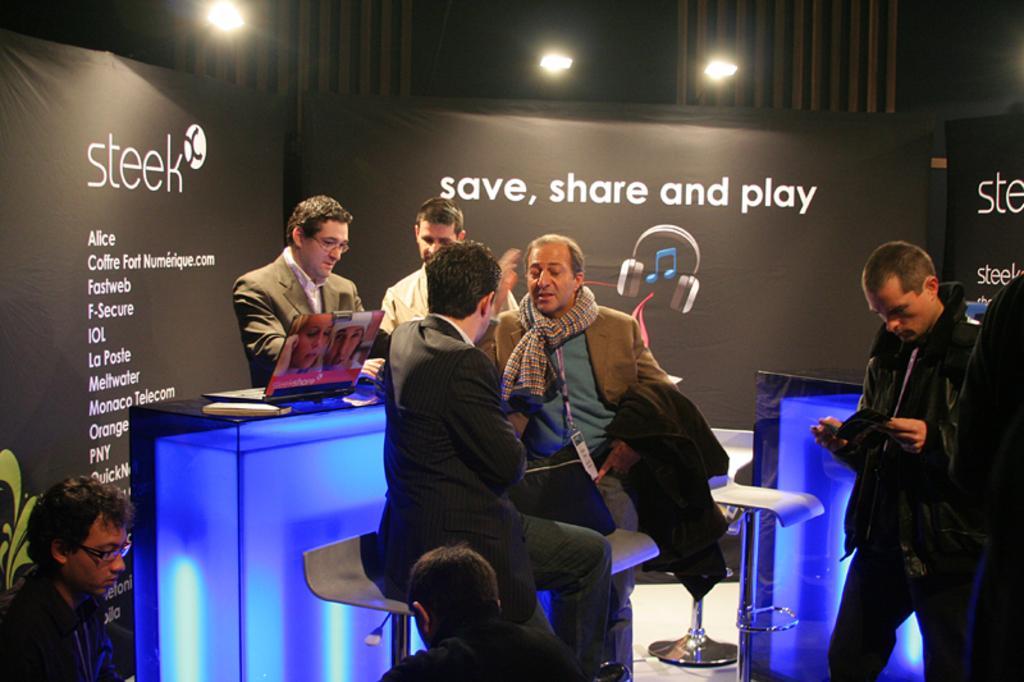Describe this image in one or two sentences. This picture describes about group of people, few are seated on the chairs and few are standing, in front of them we can see a laptop and other things on the table, in the background we can see few hoardings and lights. 